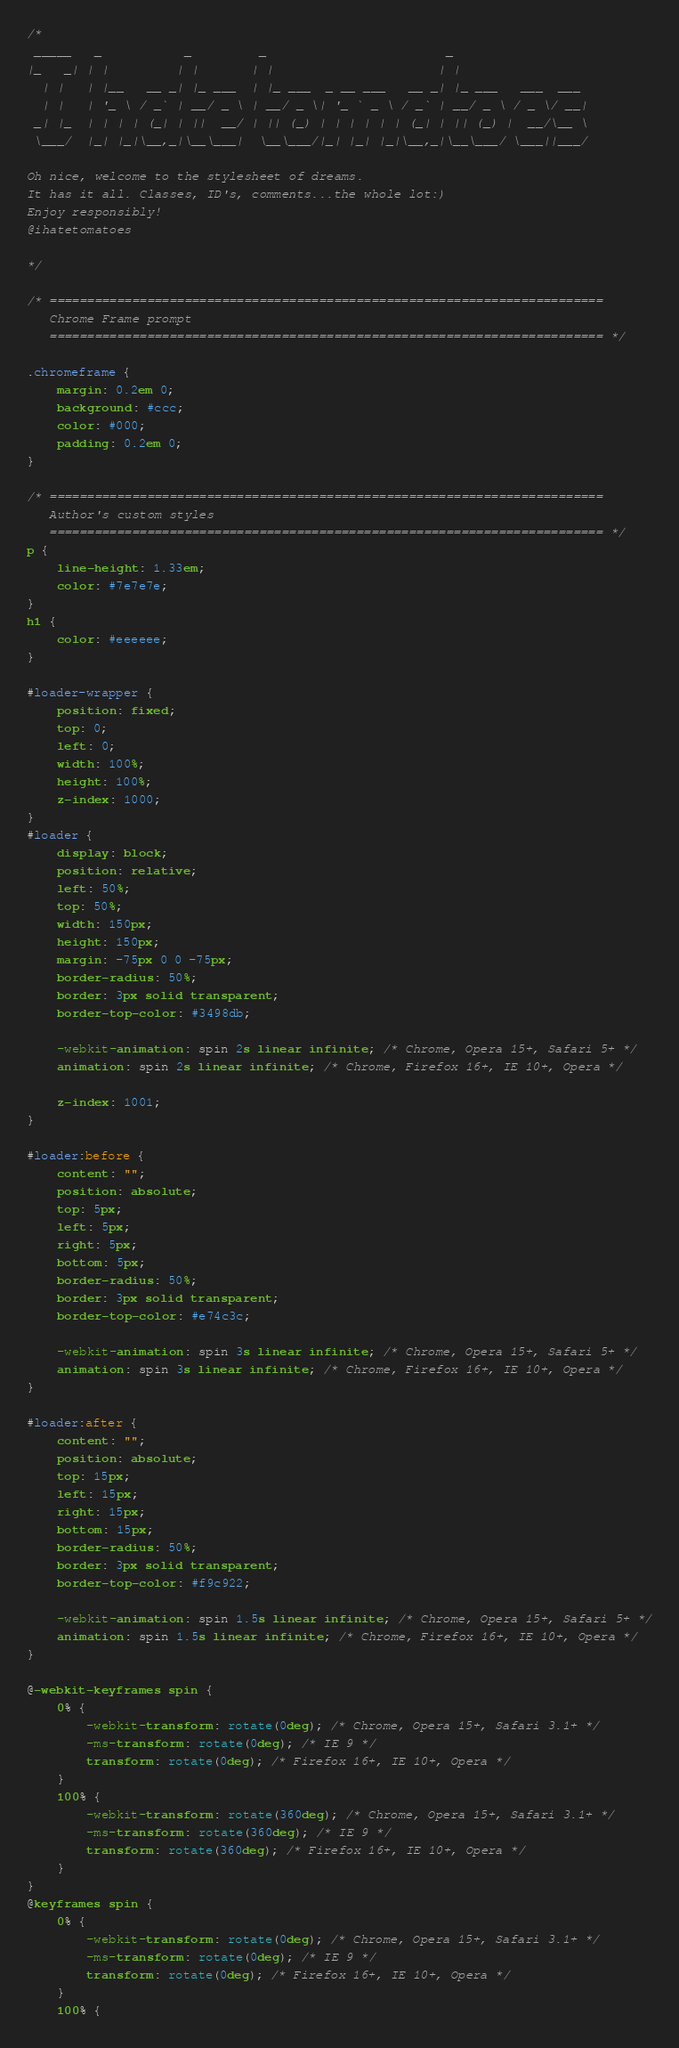Convert code to text. <code><loc_0><loc_0><loc_500><loc_500><_CSS_>/* 
 _____   _           _         _                        _                  
|_   _| | |         | |       | |                      | |                 
  | |   | |__   __ _| |_ ___  | |_ ___  _ __ ___   __ _| |_ ___   ___  ___ 
  | |   | '_ \ / _` | __/ _ \ | __/ _ \| '_ ` _ \ / _` | __/ _ \ / _ \/ __|
 _| |_  | | | | (_| | ||  __/ | || (_) | | | | | | (_| | || (_) |  __/\__ \
 \___/  |_| |_|\__,_|\__\___|  \__\___/|_| |_| |_|\__,_|\__\___/ \___||___/

Oh nice, welcome to the stylesheet of dreams. 
It has it all. Classes, ID's, comments...the whole lot:)
Enjoy responsibly!
@ihatetomatoes

*/

/* ==========================================================================
   Chrome Frame prompt
   ========================================================================== */

.chromeframe {
	margin: 0.2em 0;
	background: #ccc;
	color: #000;
	padding: 0.2em 0;
}

/* ==========================================================================
   Author's custom styles
   ========================================================================== */
p {
	line-height: 1.33em;
	color: #7e7e7e;
}
h1 {
	color: #eeeeee;
}

#loader-wrapper {
	position: fixed;
	top: 0;
	left: 0;
	width: 100%;
	height: 100%;
	z-index: 1000;
}
#loader {
	display: block;
	position: relative;
	left: 50%;
	top: 50%;
	width: 150px;
	height: 150px;
	margin: -75px 0 0 -75px;
	border-radius: 50%;
	border: 3px solid transparent;
	border-top-color: #3498db;

	-webkit-animation: spin 2s linear infinite; /* Chrome, Opera 15+, Safari 5+ */
	animation: spin 2s linear infinite; /* Chrome, Firefox 16+, IE 10+, Opera */

	z-index: 1001;
}

#loader:before {
	content: "";
	position: absolute;
	top: 5px;
	left: 5px;
	right: 5px;
	bottom: 5px;
	border-radius: 50%;
	border: 3px solid transparent;
	border-top-color: #e74c3c;

	-webkit-animation: spin 3s linear infinite; /* Chrome, Opera 15+, Safari 5+ */
	animation: spin 3s linear infinite; /* Chrome, Firefox 16+, IE 10+, Opera */
}

#loader:after {
	content: "";
	position: absolute;
	top: 15px;
	left: 15px;
	right: 15px;
	bottom: 15px;
	border-radius: 50%;
	border: 3px solid transparent;
	border-top-color: #f9c922;

	-webkit-animation: spin 1.5s linear infinite; /* Chrome, Opera 15+, Safari 5+ */
	animation: spin 1.5s linear infinite; /* Chrome, Firefox 16+, IE 10+, Opera */
}

@-webkit-keyframes spin {
	0% {
		-webkit-transform: rotate(0deg); /* Chrome, Opera 15+, Safari 3.1+ */
		-ms-transform: rotate(0deg); /* IE 9 */
		transform: rotate(0deg); /* Firefox 16+, IE 10+, Opera */
	}
	100% {
		-webkit-transform: rotate(360deg); /* Chrome, Opera 15+, Safari 3.1+ */
		-ms-transform: rotate(360deg); /* IE 9 */
		transform: rotate(360deg); /* Firefox 16+, IE 10+, Opera */
	}
}
@keyframes spin {
	0% {
		-webkit-transform: rotate(0deg); /* Chrome, Opera 15+, Safari 3.1+ */
		-ms-transform: rotate(0deg); /* IE 9 */
		transform: rotate(0deg); /* Firefox 16+, IE 10+, Opera */
	}
	100% {</code> 